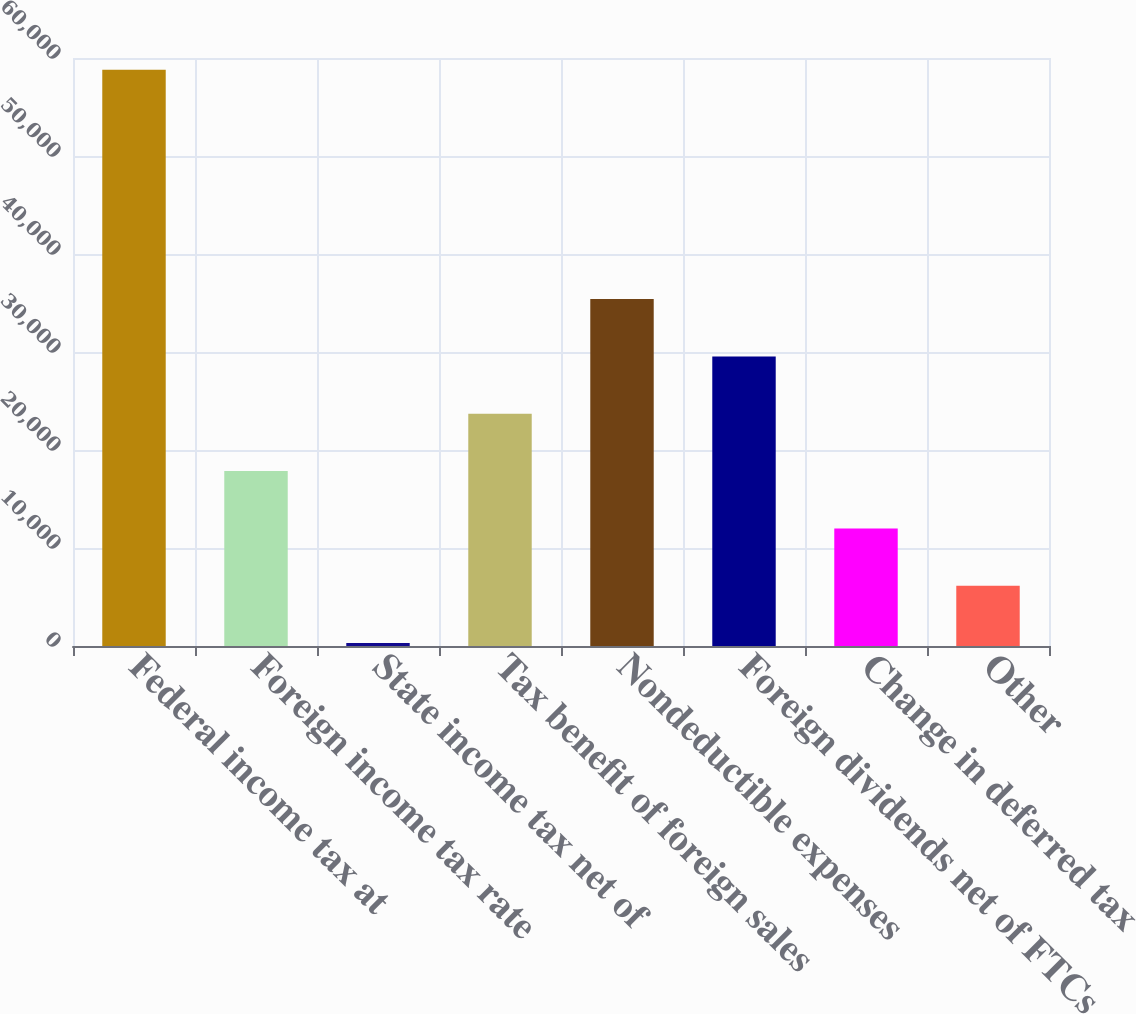<chart> <loc_0><loc_0><loc_500><loc_500><bar_chart><fcel>Federal income tax at<fcel>Foreign income tax rate<fcel>State income tax net of<fcel>Tax benefit of foreign sales<fcel>Nondeductible expenses<fcel>Foreign dividends net of FTCs<fcel>Change in deferred tax<fcel>Other<nl><fcel>58806<fcel>17851.1<fcel>299<fcel>23701.8<fcel>35403.2<fcel>29552.5<fcel>12000.4<fcel>6149.7<nl></chart> 